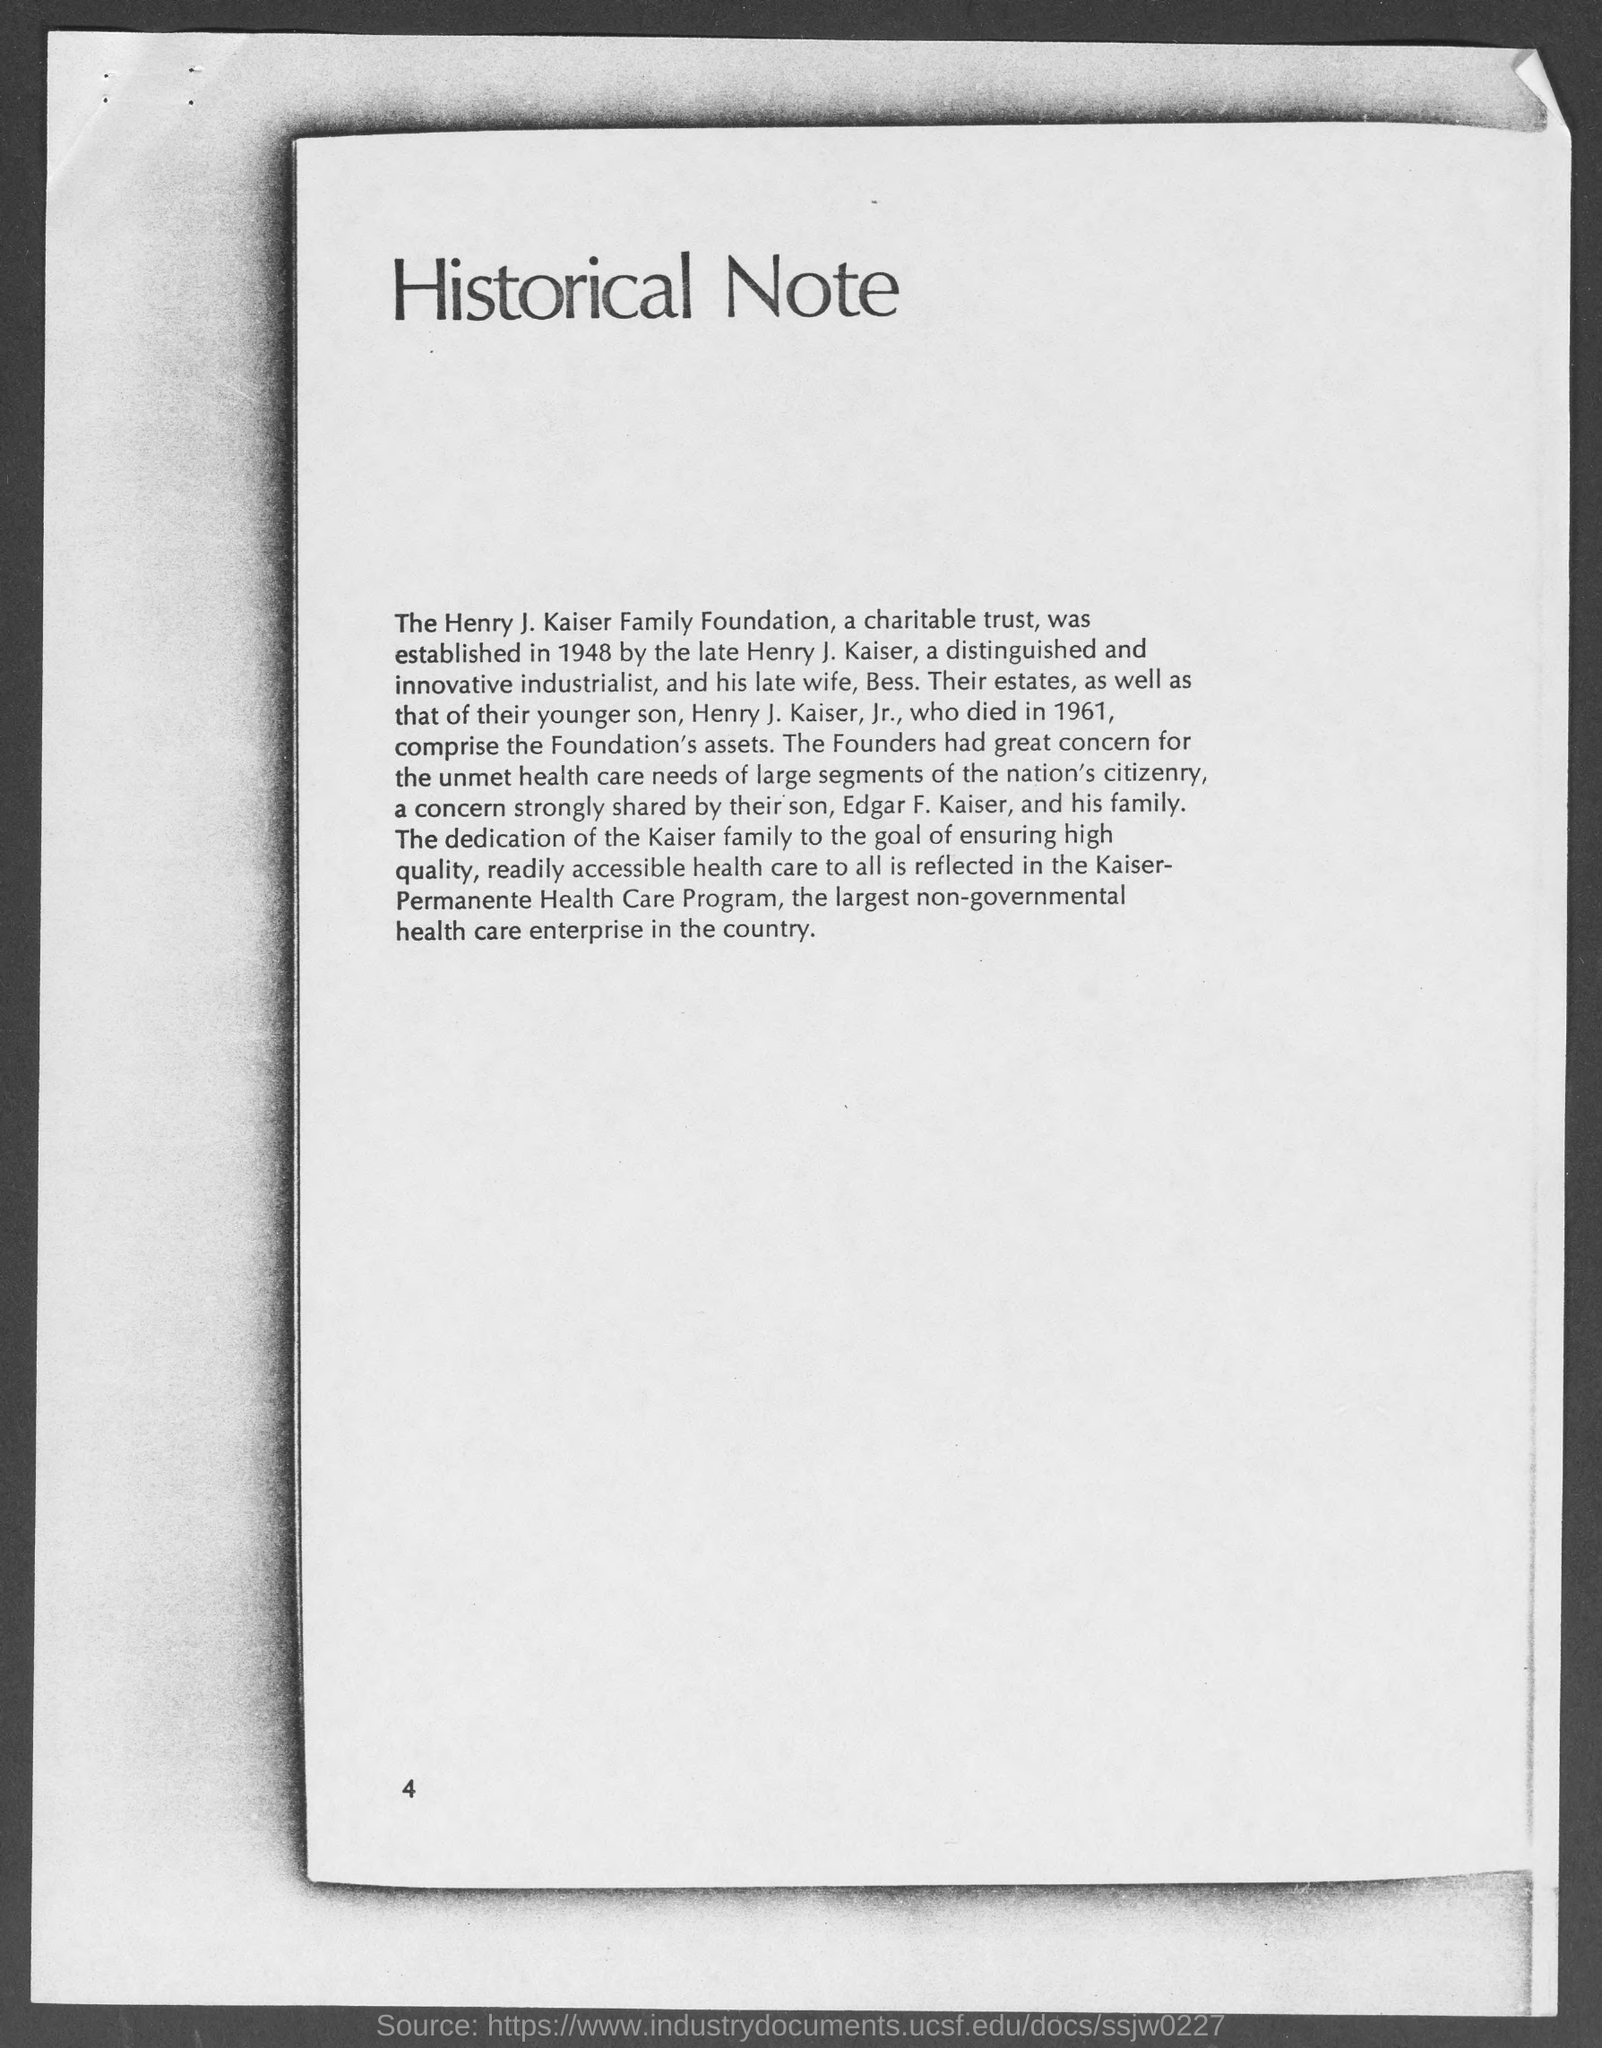What is the page number at bottom of the page?
Keep it short and to the point. 4. 